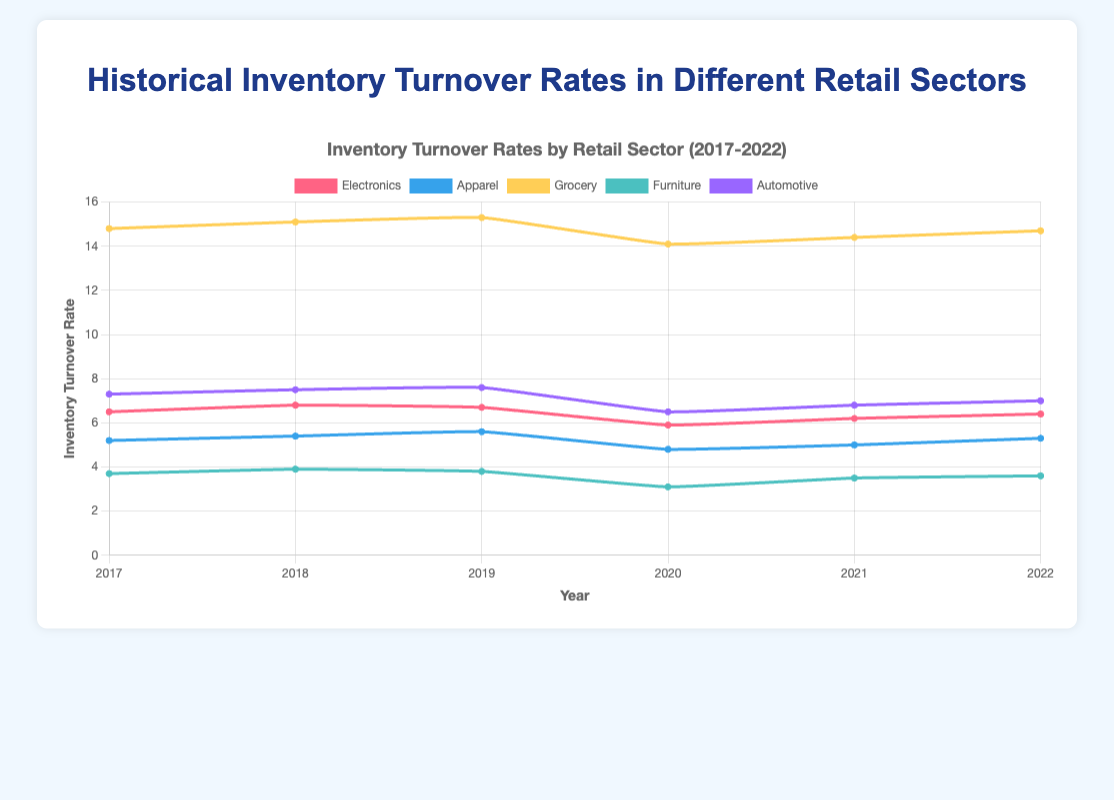Which sector had the highest inventory turnover rate in 2022? First, look at the data points for each sector in 2022. The Grocery sector has the highest value at 14.7.
Answer: Grocery Which sector showed the most significant decline in inventory turnover rate from 2019 to 2020? Calculate the difference in inventory turnover rates for each sector from 2019 to 2020 and identify the largest drop. Furniture saw the largest decline from 3.8 to 3.1, a drop of 0.7.
Answer: Furniture By how much did the inventory turnover rate of Automotive change from 2020 to 2022? Subtract the 2020 rate of 6.5 from the 2022 rate of 7.0 for the Automotive sector. The change is 7.0 - 6.5 = 0.5.
Answer: 0.5 Which two sectors had the smallest difference in their inventory turnover rates in 2021? Compare the rates of each pair of sectors in 2021 and find the smallest difference. Electronics had 6.2, and Automotive had 6.8, with a difference of 0.6.
Answer: Electronics and Automotive What is the average inventory turnover rate of the Grocery sector over the period 2017-2022? Add the Grocery rates for each year (14.8 + 15.1 + 15.3 + 14.1 + 14.4 + 14.7) and divide by 6. The sum is 88.4, so the average is 88.4 / 6 = 14.733.
Answer: 14.733 Which sector consistently had the lowest inventory turnover rate from 2017 to 2022? Check which sector has the lowest rates across all years. Furniture has the lowest rates each year: 3.7, 3.9, 3.8, 3.1, 3.5, and 3.6.
Answer: Furniture In what year did the Apparel sector achieve its highest inventory turnover rate? Examine the Apparel sector's turnover rates across the years and identify the maximum value. It reached its peak in 2019 with a rate of 5.6.
Answer: 2019 How did the Electronics sector's inventory turnover rate change from 2018 to 2020? Identify the figures for Electronics in 2018 and 2020 (6.8 in 2018, 5.9 in 2020) and calculate the difference: 6.8 - 5.9 = 0.9, indicating a decrease of 0.9.
Answer: Decreased by 0.9 In which year did the Grocery sector experience its lowest inventory turnover rate, and what was the rate? Compare the Grocery sector's rates for each year and find the minimum. It was lowest in 2020 with a rate of 14.1.
Answer: 2020, 14.1 